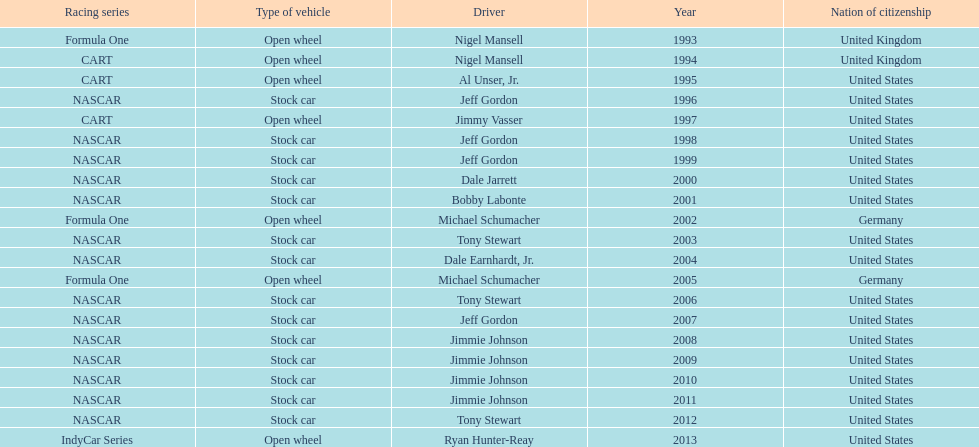Which racing series has the highest total of winners? NASCAR. 